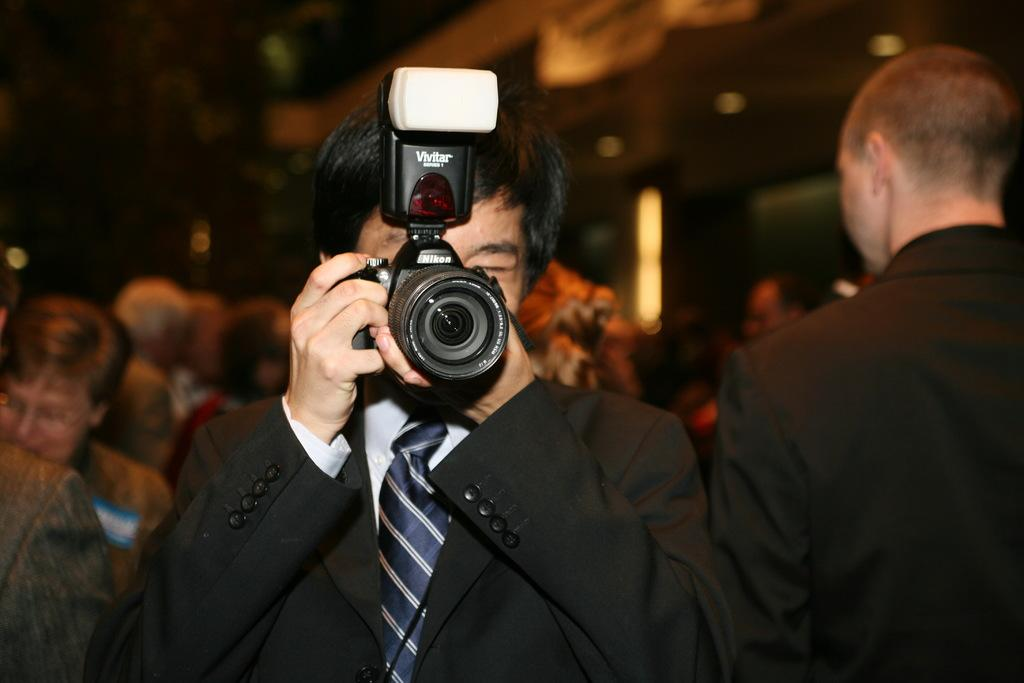What is the main subject of the image? The main subject of the image is a group of people. people. Can you describe the person in the center of the group? The person in the center is holding a camera and wearing a black shirt and a tie. What might the person in the center be doing? The person in the center might be taking a group photo, as they are holding a camera. What type of grape is the person in the center eating in the image? There is no grape present in the image, and the person in the center is holding a camera, not eating a grape. Is the doctor in the image wearing a white coat? There is no mention of a doctor or a white coat in the image, as the person in the center is wearing a black shirt and a tie. 